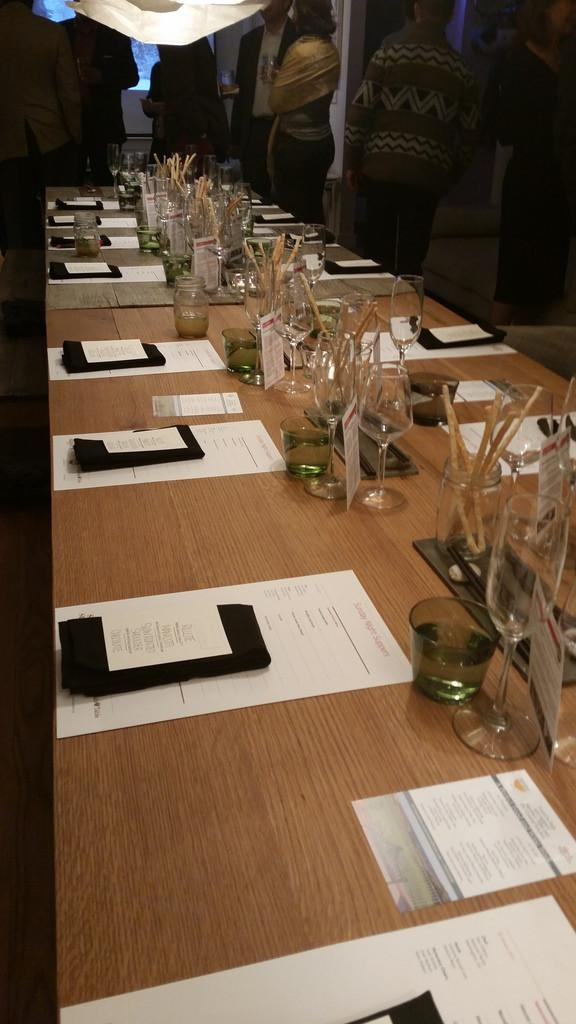What can be seen in the background of the image? There is a group of people in the background of the image. What is present on the table in the image? There is a table in the image, and on it, there are glasses and a paper. How many glasses are visible on the table? The number of glasses is not specified, but there are glasses on the table. What type of skirt is being worn by the eggnog in the image? There is no eggnog or skirt present in the image. Can you describe the crack in the paper on the table? There is no mention of a crack in the paper on the table; it is simply described as a paper. 